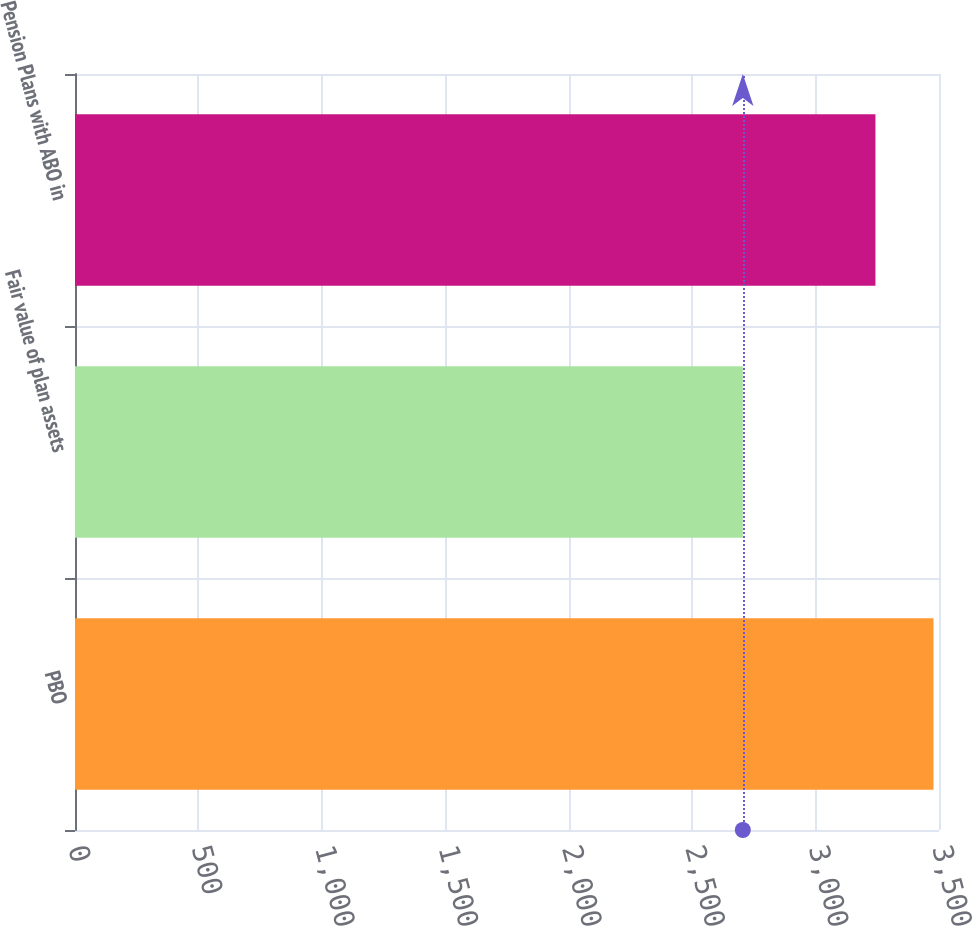<chart> <loc_0><loc_0><loc_500><loc_500><bar_chart><fcel>PBO<fcel>Fair value of plan assets<fcel>Pension Plans with ABO in<nl><fcel>3477.7<fcel>2705.3<fcel>3242.5<nl></chart> 